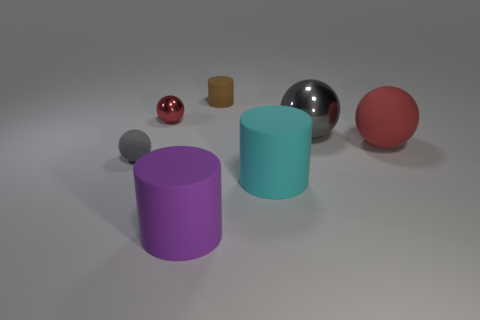Add 3 brown cubes. How many objects exist? 10 Subtract all big red balls. How many balls are left? 3 Subtract 2 balls. How many balls are left? 2 Subtract all cyan cylinders. How many cylinders are left? 2 Subtract all spheres. How many objects are left? 3 Subtract 0 blue spheres. How many objects are left? 7 Subtract all purple cylinders. Subtract all blue blocks. How many cylinders are left? 2 Subtract all gray spheres. How many purple cylinders are left? 1 Subtract all small matte things. Subtract all large purple rubber objects. How many objects are left? 4 Add 6 large gray metal spheres. How many large gray metal spheres are left? 7 